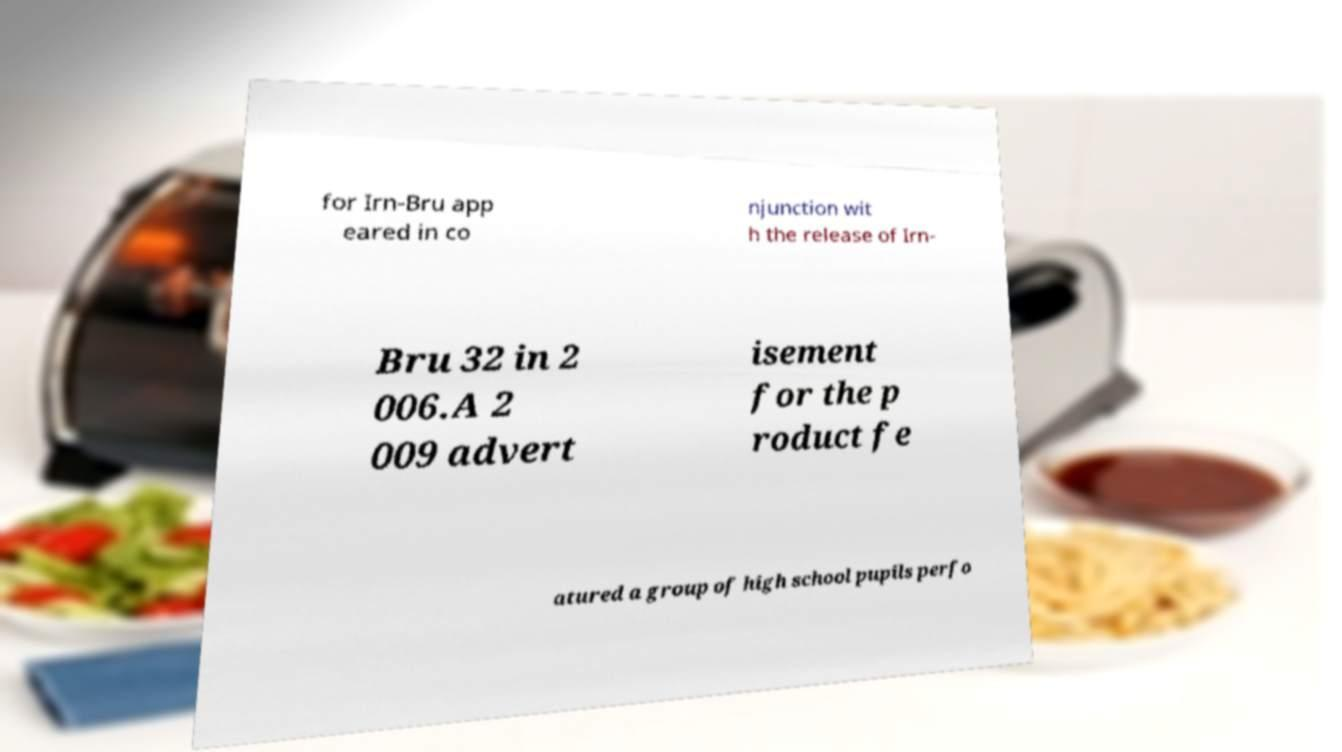For documentation purposes, I need the text within this image transcribed. Could you provide that? for Irn-Bru app eared in co njunction wit h the release of Irn- Bru 32 in 2 006.A 2 009 advert isement for the p roduct fe atured a group of high school pupils perfo 